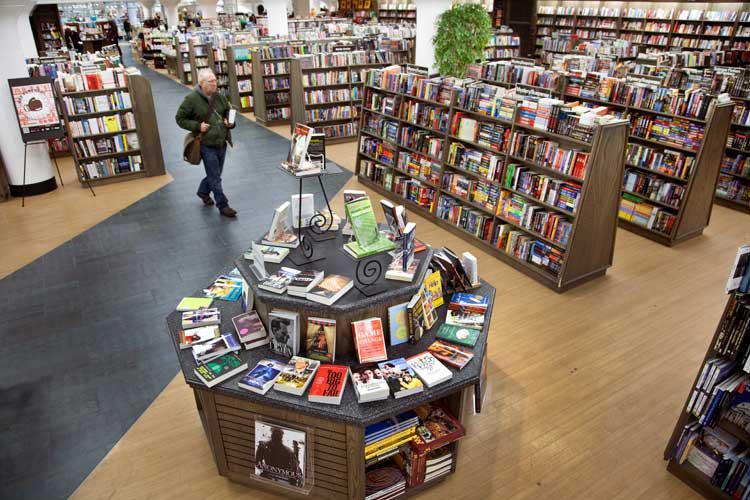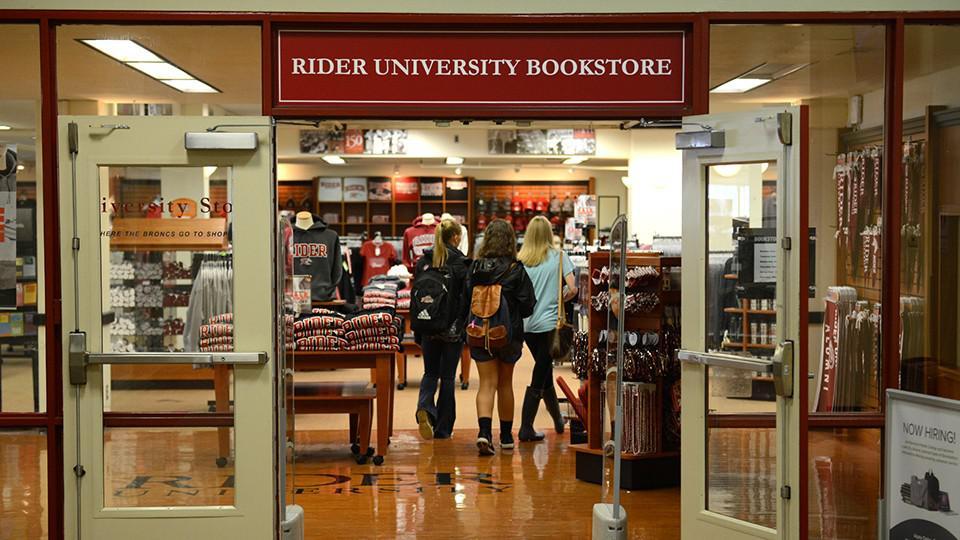The first image is the image on the left, the second image is the image on the right. Examine the images to the left and right. Is the description "One or more customers are shown in a bookstore." accurate? Answer yes or no. Yes. 